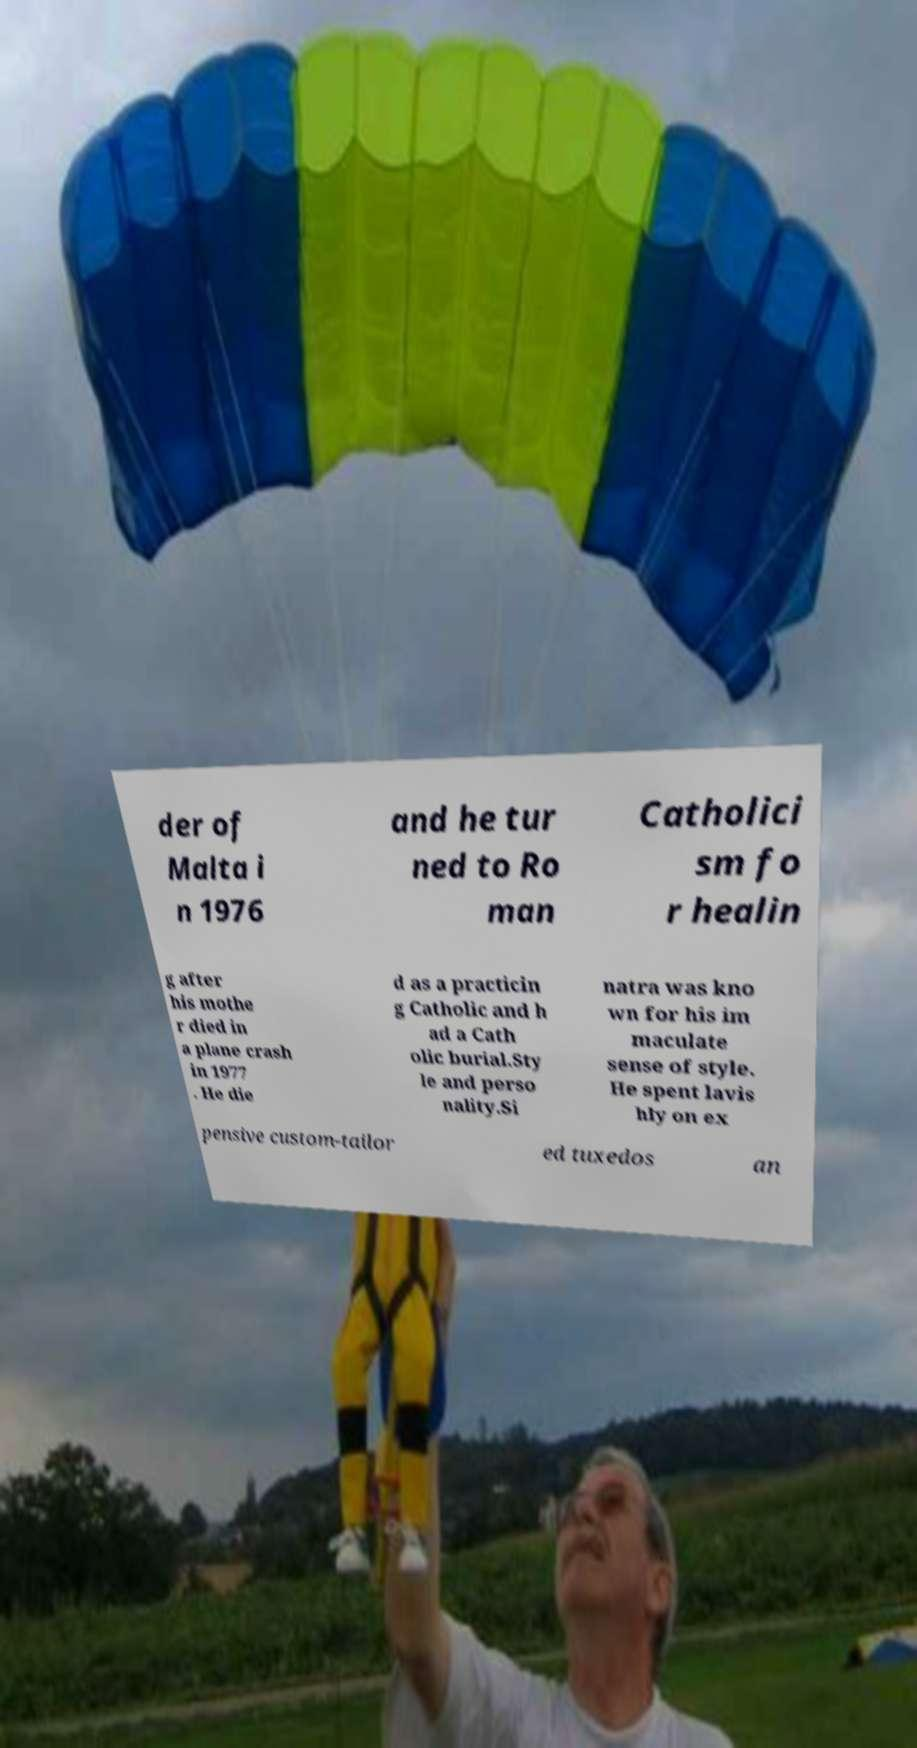What messages or text are displayed in this image? I need them in a readable, typed format. der of Malta i n 1976 and he tur ned to Ro man Catholici sm fo r healin g after his mothe r died in a plane crash in 1977 . He die d as a practicin g Catholic and h ad a Cath olic burial.Sty le and perso nality.Si natra was kno wn for his im maculate sense of style. He spent lavis hly on ex pensive custom-tailor ed tuxedos an 